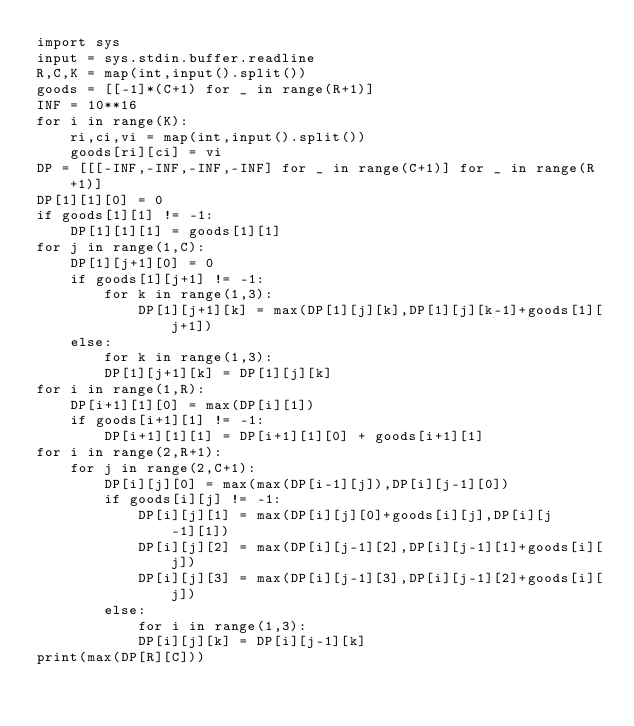Convert code to text. <code><loc_0><loc_0><loc_500><loc_500><_Python_>import sys
input = sys.stdin.buffer.readline
R,C,K = map(int,input().split())
goods = [[-1]*(C+1) for _ in range(R+1)]
INF = 10**16
for i in range(K):
    ri,ci,vi = map(int,input().split())
    goods[ri][ci] = vi
DP = [[[-INF,-INF,-INF,-INF] for _ in range(C+1)] for _ in range(R+1)]
DP[1][1][0] = 0
if goods[1][1] != -1:
    DP[1][1][1] = goods[1][1]
for j in range(1,C):
    DP[1][j+1][0] = 0
    if goods[1][j+1] != -1:
        for k in range(1,3):
            DP[1][j+1][k] = max(DP[1][j][k],DP[1][j][k-1]+goods[1][j+1])
    else:
        for k in range(1,3):
        DP[1][j+1][k] = DP[1][j][k]
for i in range(1,R):
    DP[i+1][1][0] = max(DP[i][1])
    if goods[i+1][1] != -1:
        DP[i+1][1][1] = DP[i+1][1][0] + goods[i+1][1]
for i in range(2,R+1):
    for j in range(2,C+1):
        DP[i][j][0] = max(max(DP[i-1][j]),DP[i][j-1][0])
        if goods[i][j] != -1:
            DP[i][j][1] = max(DP[i][j][0]+goods[i][j],DP[i][j-1][1])
            DP[i][j][2] = max(DP[i][j-1][2],DP[i][j-1][1]+goods[i][j])
            DP[i][j][3] = max(DP[i][j-1][3],DP[i][j-1][2]+goods[i][j])
        else:
            for i in range(1,3):
            DP[i][j][k] = DP[i][j-1][k]
print(max(DP[R][C]))</code> 